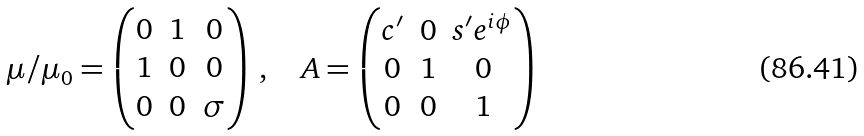Convert formula to latex. <formula><loc_0><loc_0><loc_500><loc_500>\mu / \mu _ { 0 } = \begin{pmatrix} 0 & 1 & 0 \\ 1 & 0 & 0 \\ 0 & 0 & \sigma \end{pmatrix} \, , \quad A = \begin{pmatrix} c ^ { \prime } & 0 & s ^ { \prime } e ^ { i \phi } \\ 0 & 1 & 0 \\ 0 & 0 & 1 \end{pmatrix}</formula> 